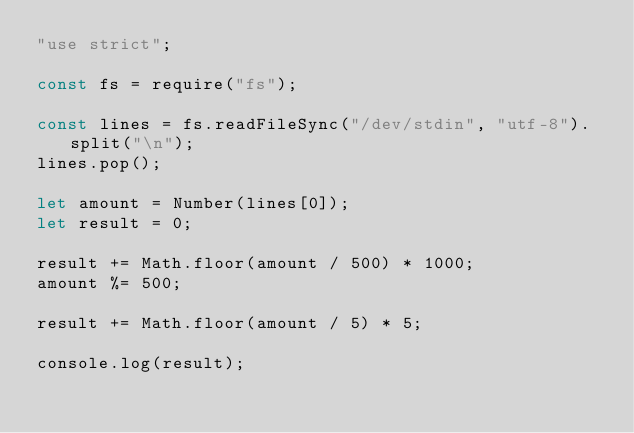<code> <loc_0><loc_0><loc_500><loc_500><_JavaScript_>"use strict";

const fs = require("fs");

const lines = fs.readFileSync("/dev/stdin", "utf-8").split("\n");
lines.pop();

let amount = Number(lines[0]);
let result = 0;

result += Math.floor(amount / 500) * 1000;
amount %= 500;

result += Math.floor(amount / 5) * 5;

console.log(result);
</code> 